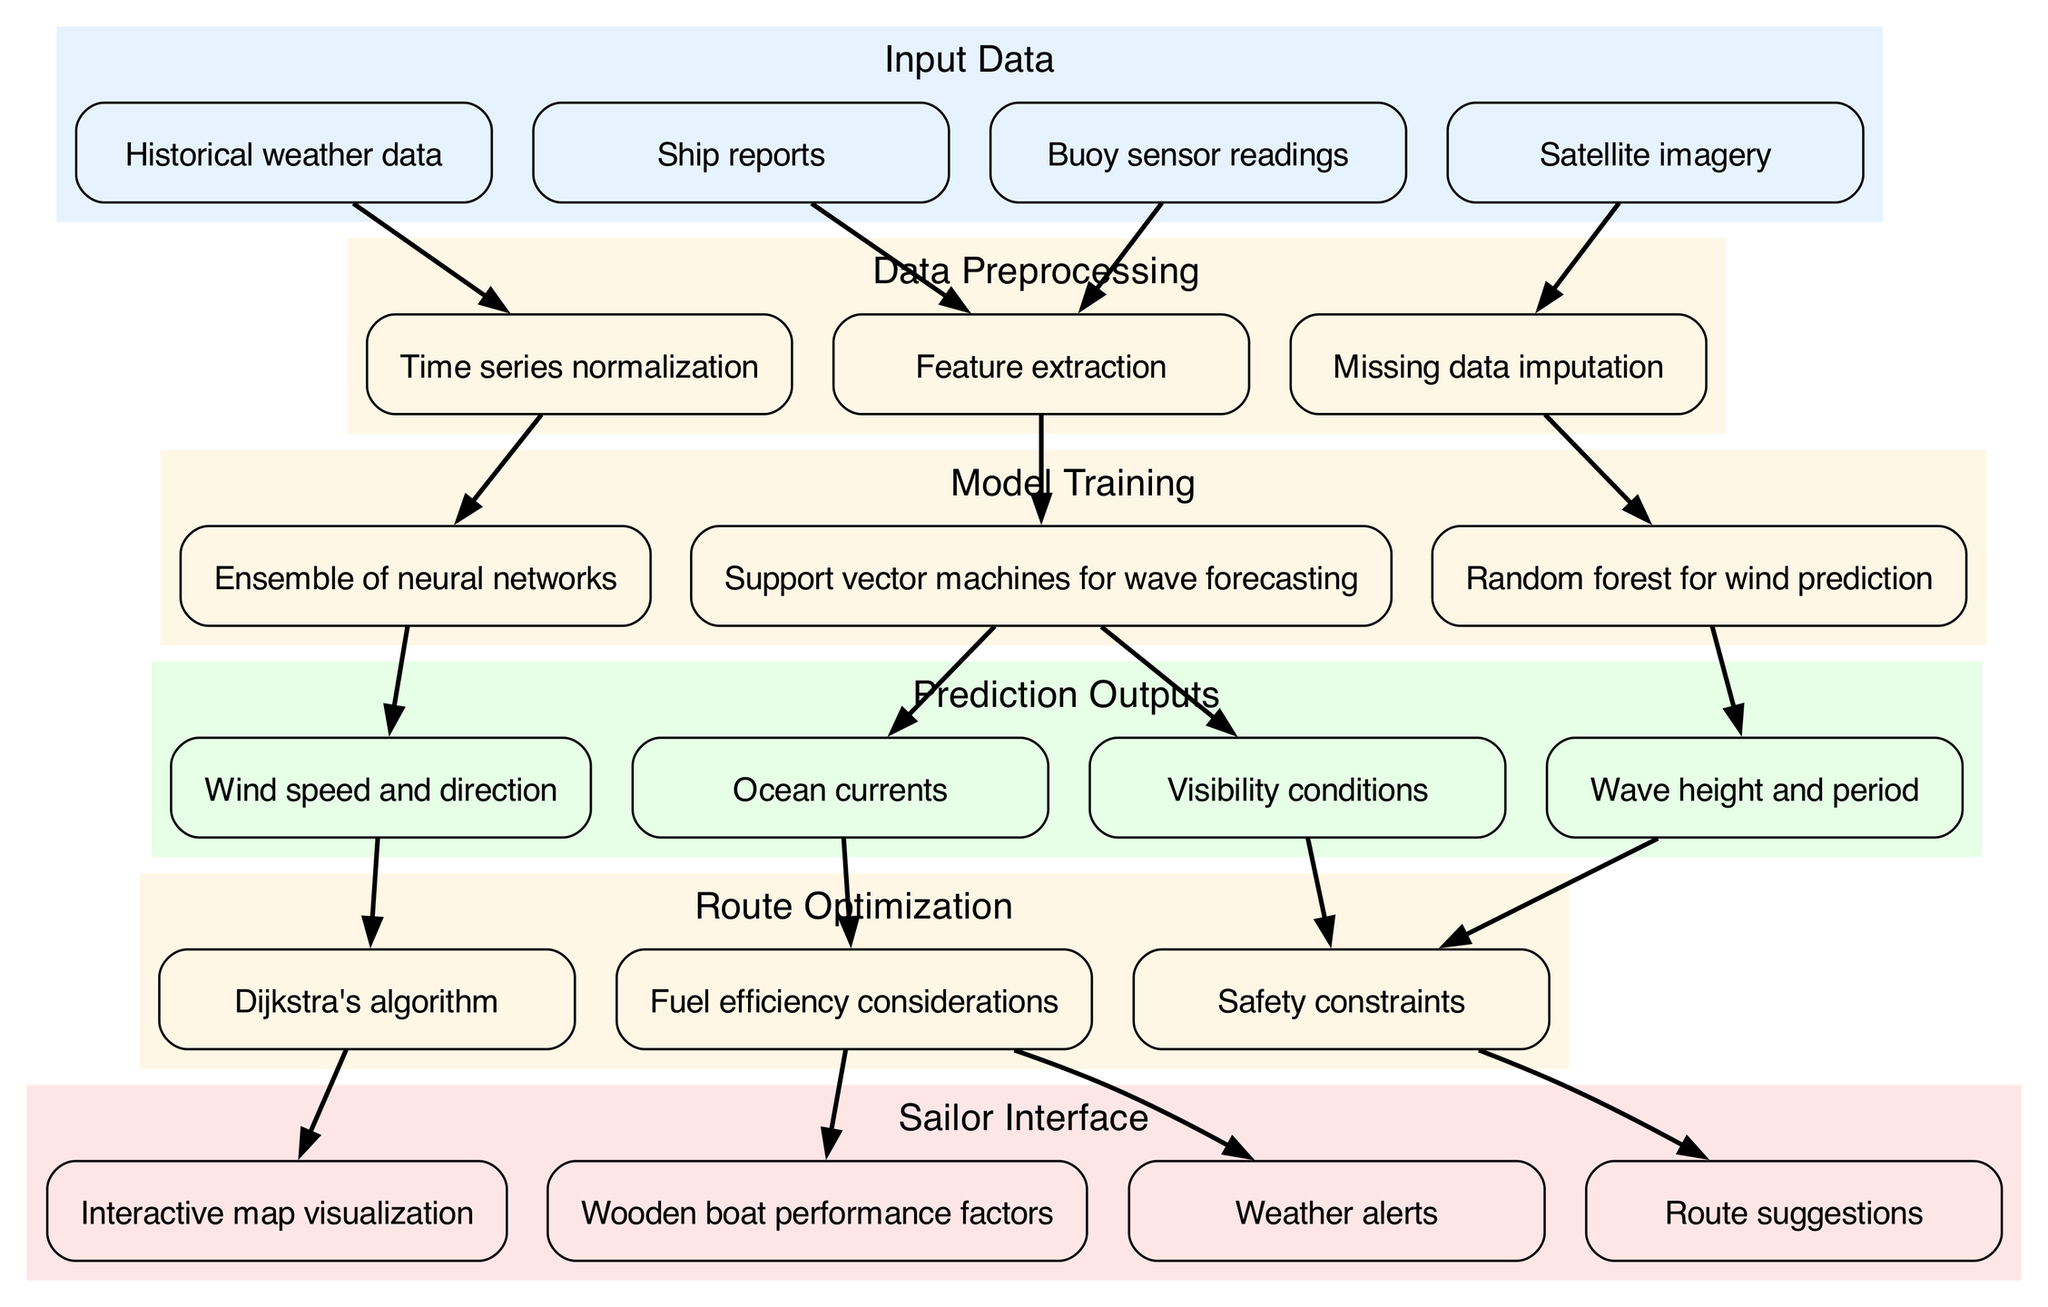What are the input data types used in the pipeline? The input data consists of four types: historical weather data, satellite imagery, buoy sensor readings, and ship reports. Each type is represented as a node in the input data section of the diagram.
Answer: Historical weather data, satellite imagery, buoy sensor readings, ship reports How many different preprocessing steps are there? There are three preprocessing steps indicated in the diagram: time series normalization, missing data imputation, and feature extraction. These steps are within their own section in the diagram.
Answer: 3 What is the output for wave forecasting? The output of wave forecasting is represented by the support vector machines node, which points to two outputs: ocean currents and visibility conditions. Thus, the specific output for wave forecasting is "ocean currents".
Answer: Ocean currents What algorithm is used for route optimization? The diagram explicitly labels Dijkstra's algorithm as the method used for route optimization, showing its central role in calculating optimal routes in the output section.
Answer: Dijkstra's algorithm What do the route optimization outputs include? The outputs from the route optimization stage include "Interactive map visualization," "Route suggestions," "Weather alerts," and "Wooden boat performance factors." These outputs are shown as nodes connected to the Dijkstra's algorithm node in the diagram.
Answer: Interactive map visualization, Route suggestions, Weather alerts, Wooden boat performance factors Which model is responsible for predicting wind speed and direction? The ensemble of neural networks is the model designated to predict wind speed and direction as illustrated by the connecting edge from the model to the respective output node in the diagram.
Answer: Ensemble of neural networks How does the input "Buoy sensor readings" contribute to model training? The buoy sensor readings undergo feature extraction during the data preprocessing stage, which then feeds into the model training stage, specifically into support vector machines for wave forecasting.
Answer: Feature extraction What are the safety constraints considered during route optimization? Safety constraints are considered as part of the route optimization process, as indicated by the connection from the "wave height and period" and "visibility conditions" outputs to the safety constraints node.
Answer: Safety constraints How many prediction outputs are there overall? The diagram shows four distinct prediction outputs: wind speed and direction, wave height and period, ocean currents, and visibility conditions, thus totaling to four.
Answer: 4 